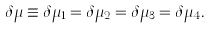Convert formula to latex. <formula><loc_0><loc_0><loc_500><loc_500>\delta \mu \equiv \delta \mu _ { 1 } = \delta \mu _ { 2 } = \delta \mu _ { 3 } = \delta \mu _ { 4 } .</formula> 